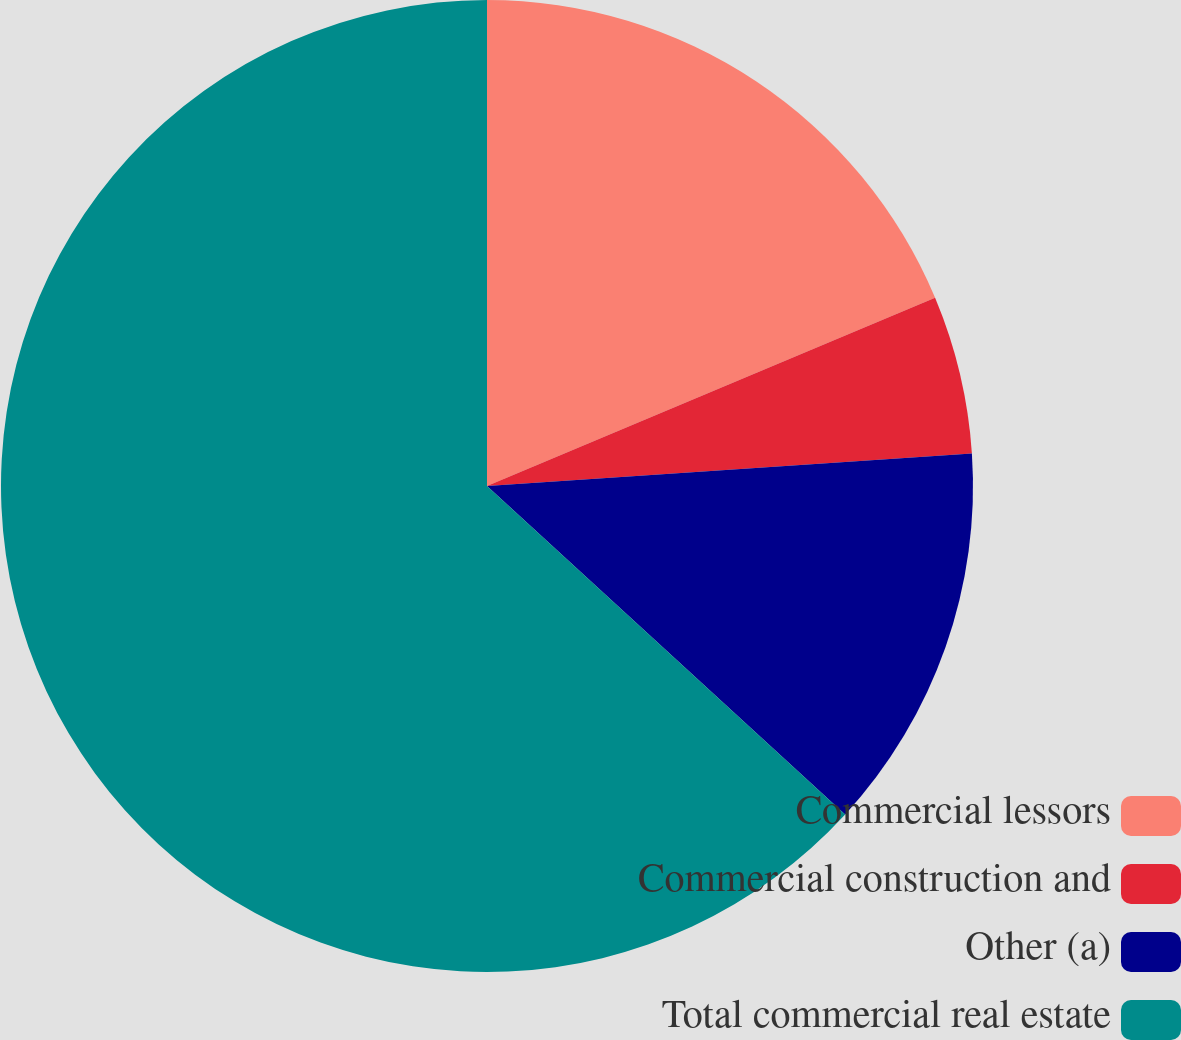Convert chart to OTSL. <chart><loc_0><loc_0><loc_500><loc_500><pie_chart><fcel>Commercial lessors<fcel>Commercial construction and<fcel>Other (a)<fcel>Total commercial real estate<nl><fcel>18.67%<fcel>5.26%<fcel>12.88%<fcel>63.18%<nl></chart> 